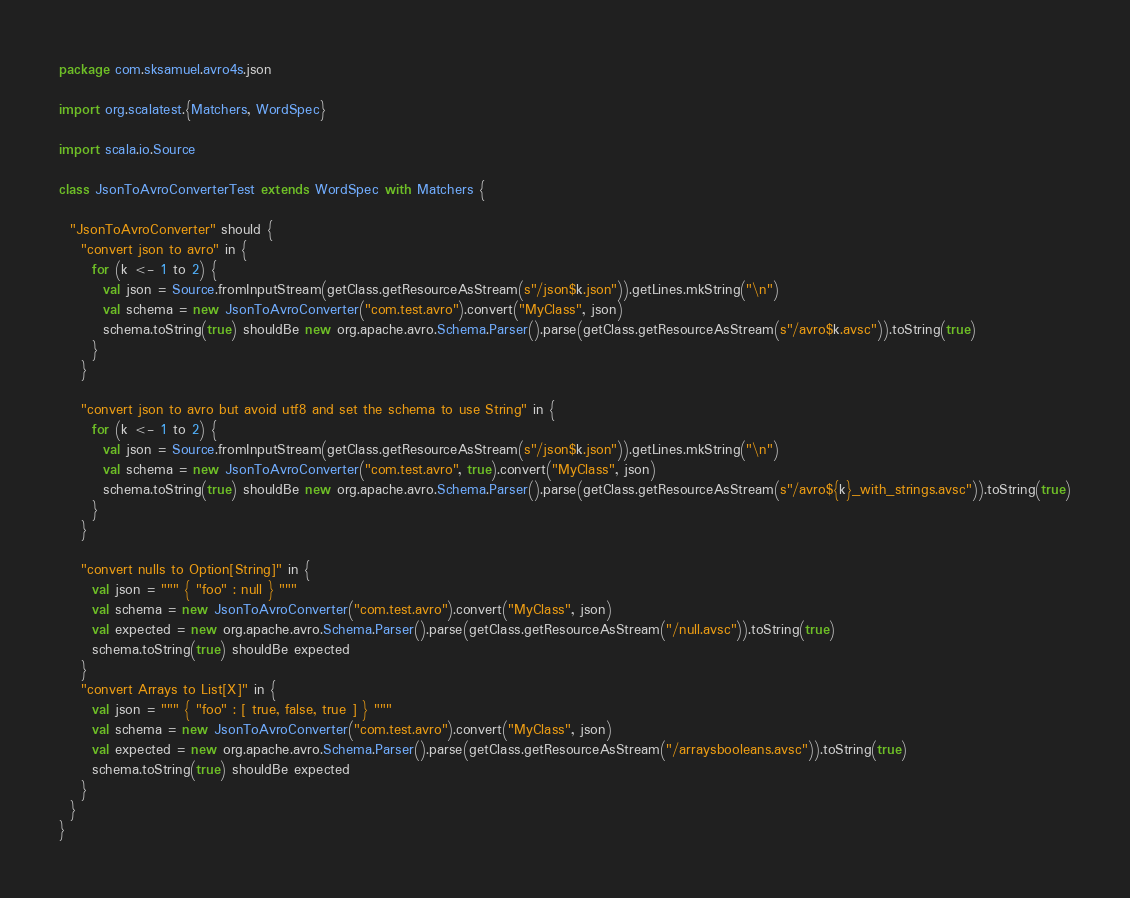<code> <loc_0><loc_0><loc_500><loc_500><_Scala_>package com.sksamuel.avro4s.json

import org.scalatest.{Matchers, WordSpec}

import scala.io.Source

class JsonToAvroConverterTest extends WordSpec with Matchers {

  "JsonToAvroConverter" should {
    "convert json to avro" in {
      for (k <- 1 to 2) {
        val json = Source.fromInputStream(getClass.getResourceAsStream(s"/json$k.json")).getLines.mkString("\n")
        val schema = new JsonToAvroConverter("com.test.avro").convert("MyClass", json)
        schema.toString(true) shouldBe new org.apache.avro.Schema.Parser().parse(getClass.getResourceAsStream(s"/avro$k.avsc")).toString(true)
      }
    }

    "convert json to avro but avoid utf8 and set the schema to use String" in {
      for (k <- 1 to 2) {
        val json = Source.fromInputStream(getClass.getResourceAsStream(s"/json$k.json")).getLines.mkString("\n")
        val schema = new JsonToAvroConverter("com.test.avro", true).convert("MyClass", json)
        schema.toString(true) shouldBe new org.apache.avro.Schema.Parser().parse(getClass.getResourceAsStream(s"/avro${k}_with_strings.avsc")).toString(true)
      }
    }

    "convert nulls to Option[String]" in {
      val json = """ { "foo" : null } """
      val schema = new JsonToAvroConverter("com.test.avro").convert("MyClass", json)
      val expected = new org.apache.avro.Schema.Parser().parse(getClass.getResourceAsStream("/null.avsc")).toString(true)
      schema.toString(true) shouldBe expected
    }
    "convert Arrays to List[X]" in {
      val json = """ { "foo" : [ true, false, true ] } """
      val schema = new JsonToAvroConverter("com.test.avro").convert("MyClass", json)
      val expected = new org.apache.avro.Schema.Parser().parse(getClass.getResourceAsStream("/arraysbooleans.avsc")).toString(true)
      schema.toString(true) shouldBe expected
    }
  }
}
</code> 